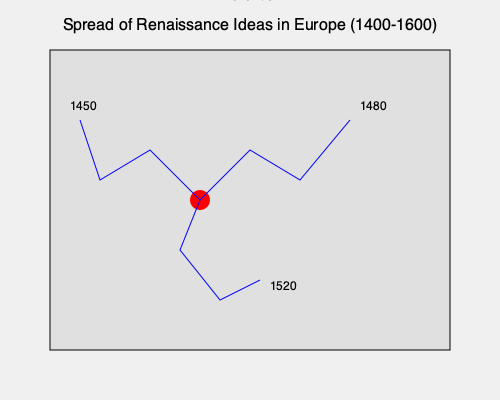Based on the map depicting the spread of Renaissance ideas from Florence, which period saw the most extensive geographical expansion of these concepts across Europe? To answer this question, we need to analyze the map and its timeline:

1. The map shows Florence as the central point (red dot) from which Renaissance ideas spread.
2. There are three main paths of expansion, represented by blue lines.
3. Each path is labeled with a year, indicating when Renaissance ideas reached that extent:
   - Northwestern path: labeled 1450
   - Northeastern path: labeled 1480
   - Southern path: labeled 1520

4. To determine the period of most extensive geographical expansion, we need to compare the time intervals and the extent of spread:
   - From 1400 (start of Renaissance) to 1450: Initial spread to the northwest
   - From 1450 to 1480: Further spread to the northeast
   - From 1480 to 1520: Additional spread to the south

5. The period from 1450 to 1480 covers the expansion to both northwest and northeast, encompassing the largest geographical area on the map.

Therefore, the period between 1450 and 1480 saw the most extensive geographical expansion of Renaissance ideas across Europe according to this map.
Answer: 1450-1480 